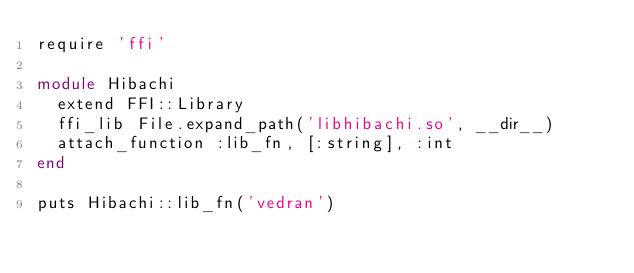<code> <loc_0><loc_0><loc_500><loc_500><_Ruby_>require 'ffi'

module Hibachi
  extend FFI::Library
  ffi_lib File.expand_path('libhibachi.so', __dir__)
  attach_function :lib_fn, [:string], :int
end

puts Hibachi::lib_fn('vedran')
</code> 